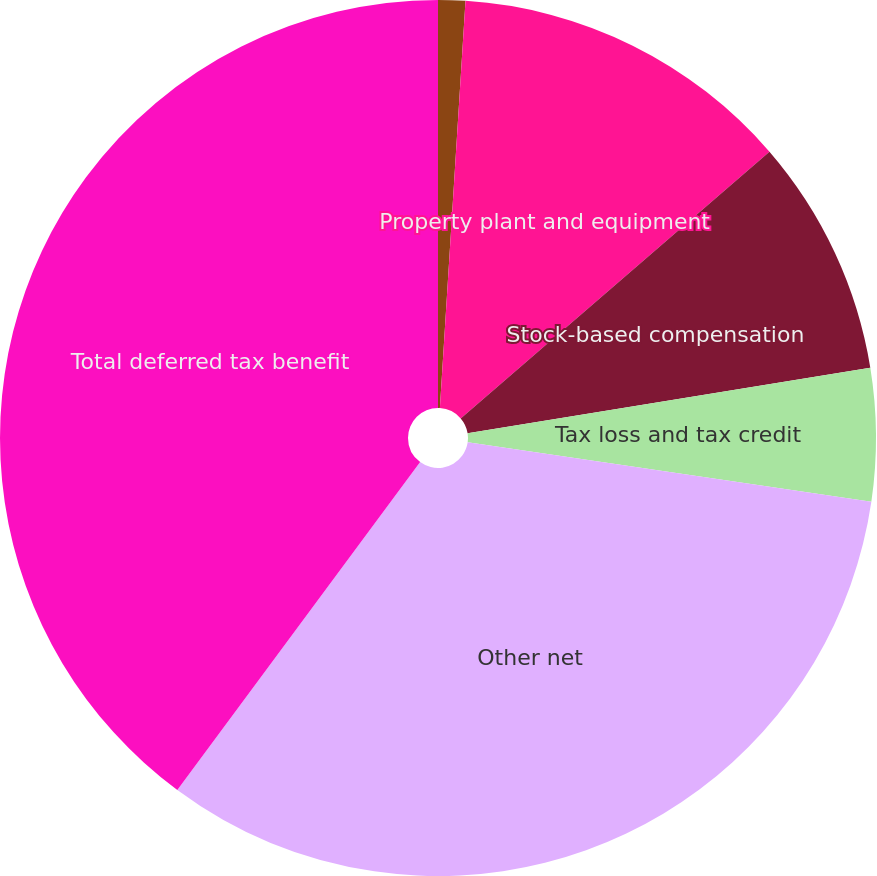Convert chart. <chart><loc_0><loc_0><loc_500><loc_500><pie_chart><fcel>Goodwill and intangible assets<fcel>Property plant and equipment<fcel>Stock-based compensation<fcel>Tax loss and tax credit<fcel>Other net<fcel>Total deferred tax benefit<nl><fcel>1.0%<fcel>12.66%<fcel>8.77%<fcel>4.89%<fcel>32.82%<fcel>39.85%<nl></chart> 